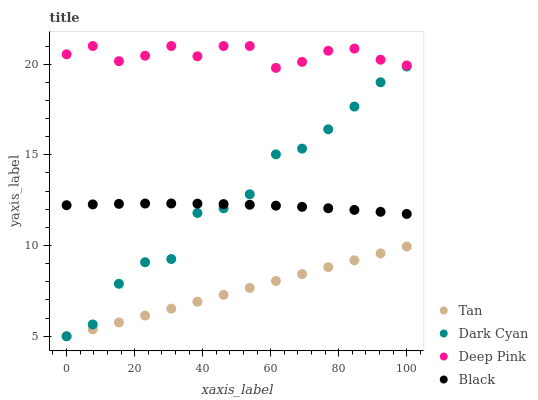Does Tan have the minimum area under the curve?
Answer yes or no. Yes. Does Deep Pink have the maximum area under the curve?
Answer yes or no. Yes. Does Deep Pink have the minimum area under the curve?
Answer yes or no. No. Does Tan have the maximum area under the curve?
Answer yes or no. No. Is Tan the smoothest?
Answer yes or no. Yes. Is Dark Cyan the roughest?
Answer yes or no. Yes. Is Deep Pink the smoothest?
Answer yes or no. No. Is Deep Pink the roughest?
Answer yes or no. No. Does Dark Cyan have the lowest value?
Answer yes or no. Yes. Does Deep Pink have the lowest value?
Answer yes or no. No. Does Deep Pink have the highest value?
Answer yes or no. Yes. Does Tan have the highest value?
Answer yes or no. No. Is Black less than Deep Pink?
Answer yes or no. Yes. Is Deep Pink greater than Dark Cyan?
Answer yes or no. Yes. Does Tan intersect Dark Cyan?
Answer yes or no. Yes. Is Tan less than Dark Cyan?
Answer yes or no. No. Is Tan greater than Dark Cyan?
Answer yes or no. No. Does Black intersect Deep Pink?
Answer yes or no. No. 